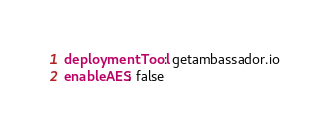Convert code to text. <code><loc_0><loc_0><loc_500><loc_500><_YAML_>deploymentTool: getambassador.io
enableAES: false
</code> 